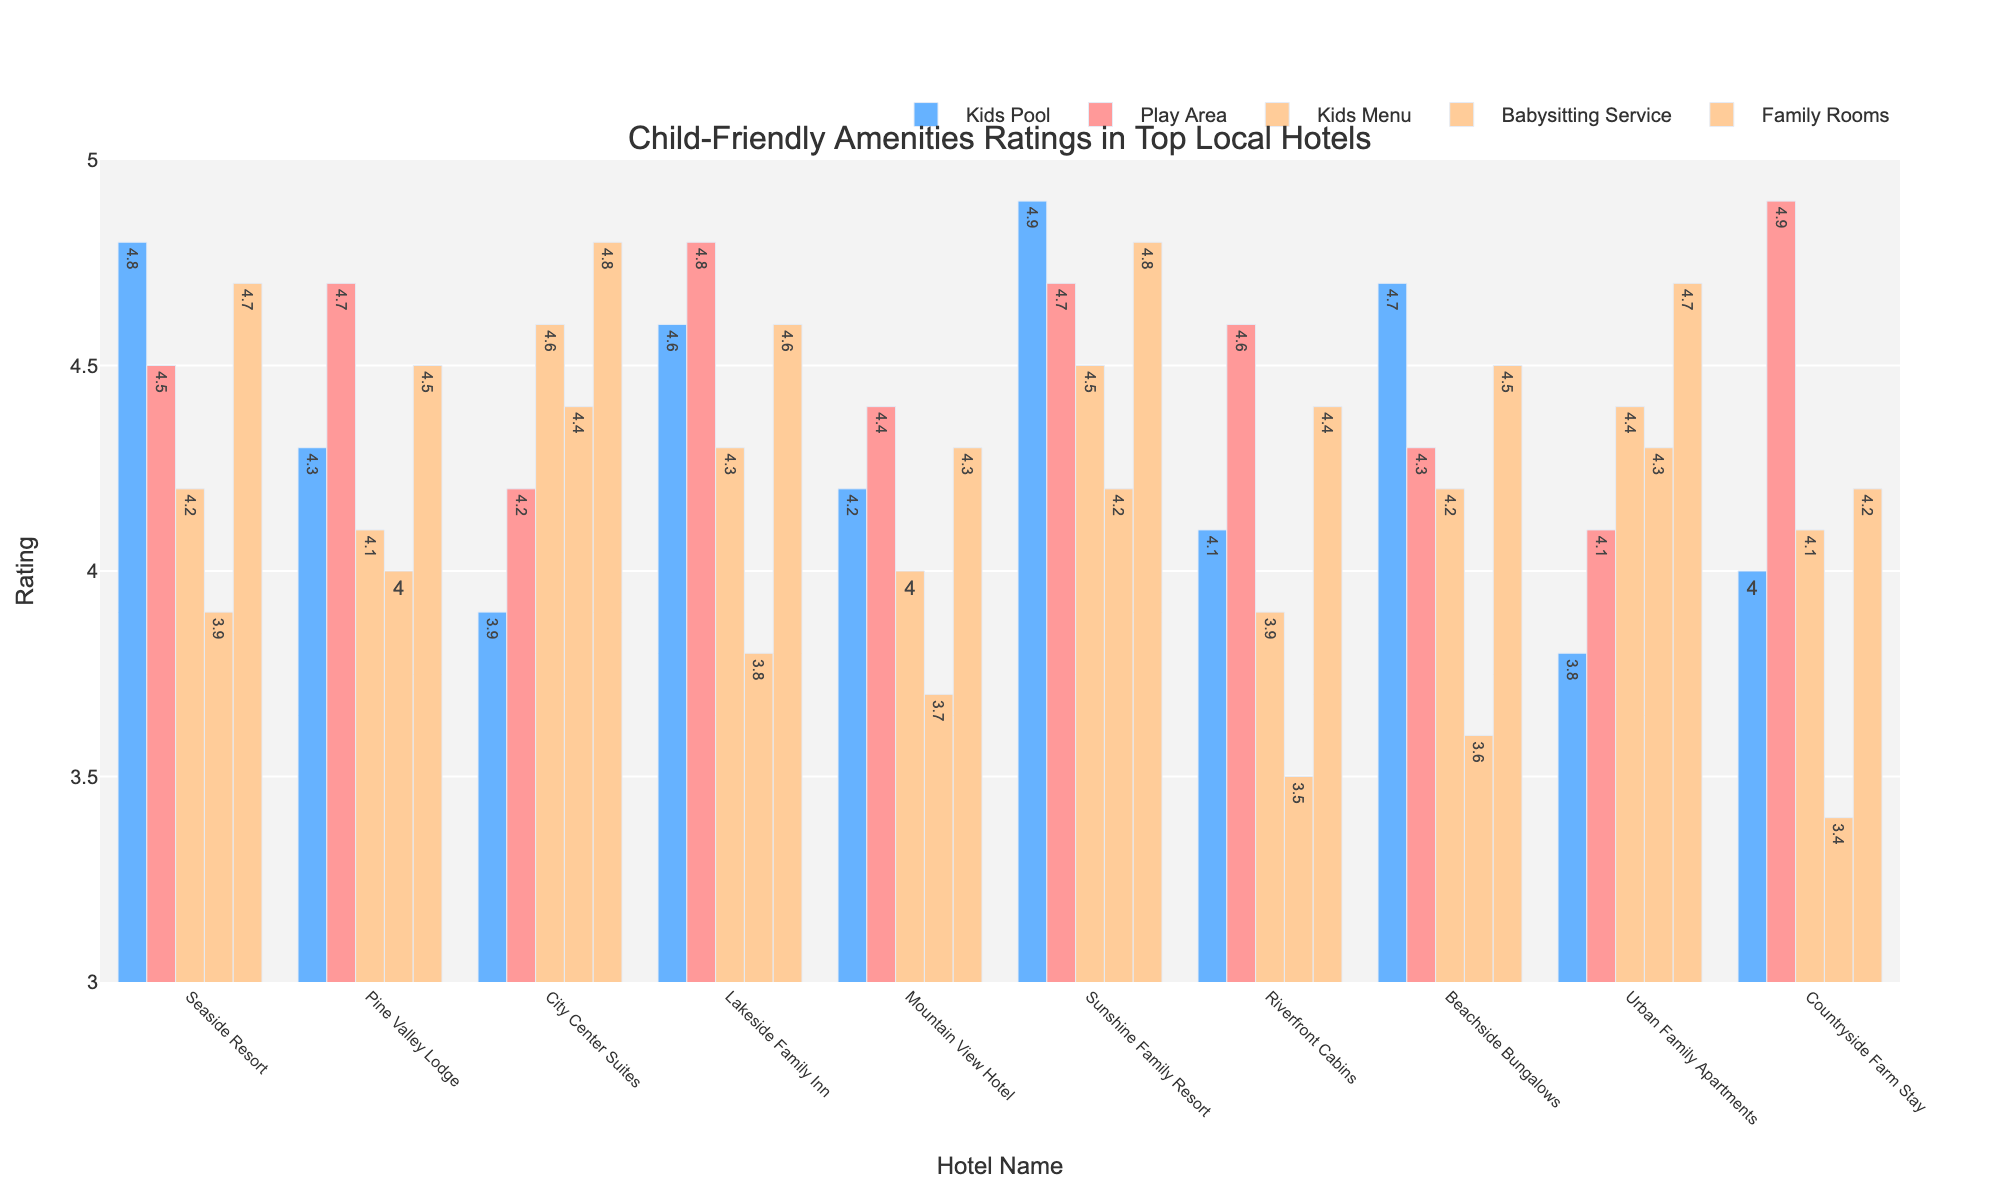Which hotel has the highest rating for the Kids Pool? By observing the heights of the bars for the 'Kids Pool' across all hotels, we can determine the highest rating. Seaside Resort has the highest bar for the Kids Pool category.
Answer: Seaside Resort What's the difference in the rating of Family Rooms between Seaside Resort and Riverfront Cabins? First, locate the bars for 'Family Rooms' for both Seaside Resort and Riverfront Cabins. Seaside Resort has a rating of 4.7 and Riverfront Cabins has a rating of 4.4. Subtract Riverfront Cabins' rating from Seaside Resort's rating (4.7 - 4.4).
Answer: 0.3 Which two amenities have the highest average rating across all hotels? Calculate the average rating for each amenity across all hotels. The averages are: Kids Pool (4.33), Play Area (4.51), Kids Menu (4.23), Babysitting Service (3.96), Family Rooms (4.55). Play Area and Family Rooms have the highest averages.
Answer: Play Area and Family Rooms Does Sunshine Family Resort have higher ratings for Kids Menu or Babysitting Service? Compare the heights of the bars for 'Kids Menu' and 'Babysitting Service' for Sunshine Family Resort. Kids Menu has a higher rating (4.5) compared to Babysitting Service (4.2).
Answer: Kids Menu Which hotel has the lowest rating for Babysitting Service? Look for the shortest bar in the 'Babysitting Service' category. It belongs to Countryside Farm Stay with a rating of 3.4.
Answer: Countryside Farm Stay Is Pine Valley Lodge's rating for Play Area greater than its rating for Family Rooms? Compare the bars for Play Area and Family Rooms for Pine Valley Lodge. Play Area is rated 4.7, and Family Rooms are rated 4.5, making the Play Area's rating greater.
Answer: Yes, greater Among all hotels, which hotel has the highest overall average rating computed based on all child-friendly amenities? To find this, first calculate the average rating for each hotel by summing their ratings for all five amenities and dividing by 5. For example, Seaside Resort's average is (4.8+4.5+4.2+3.9+4.7)/5 = 4.42. Perform a similar calculation for all hotels and compare. Sunshine Family Resort has the highest overall average rating.
Answer: Sunshine Family Resort What are the two lowest ratings received by City Center Suites, and for which amenities? Review the bars representing City Center Suites' ratings. The lowest ratings are 3.9 for Kids Pool and 4.2 for Play Area.
Answer: Kids Pool (3.9) and Play Area (4.2) Which hotel has equal ratings for Kids Pool and Play Area? Identify hotels with bars of equal height for Kids Pool and Play Area. Countryside Farm Stay has equal ratings of 4.9 for both amenities.
Answer: Countryside Farm Stay What is the median rating for the Babysitting Service across all hotels? List all the ratings for Babysitting Services (3.9, 4.0, 4.4, 3.8, 3.7, 4.2, 3.5, 3.6, 4.3, 3.4), sort them (3.4, 3.5, 3.6, 3.7, 3.8, 3.9, 4.0, 4.2, 4.3, 4.4), and find the middle value. The median is the average of the 5th and 6th values ((3.8 + 3.9)/2).
Answer: 3.85 